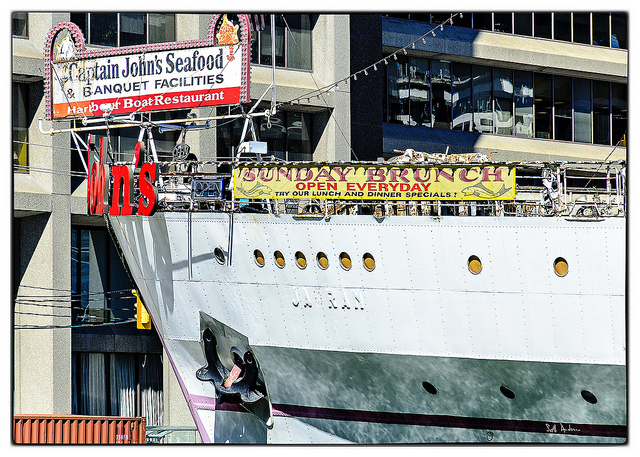Identify the text displayed in this image. OPEN EVERYDAY SUNDAY BRUNCH BANQUET DINNER AND LUNCH TRY Restaurant Boat FACILITIES Seafood John's Captain 